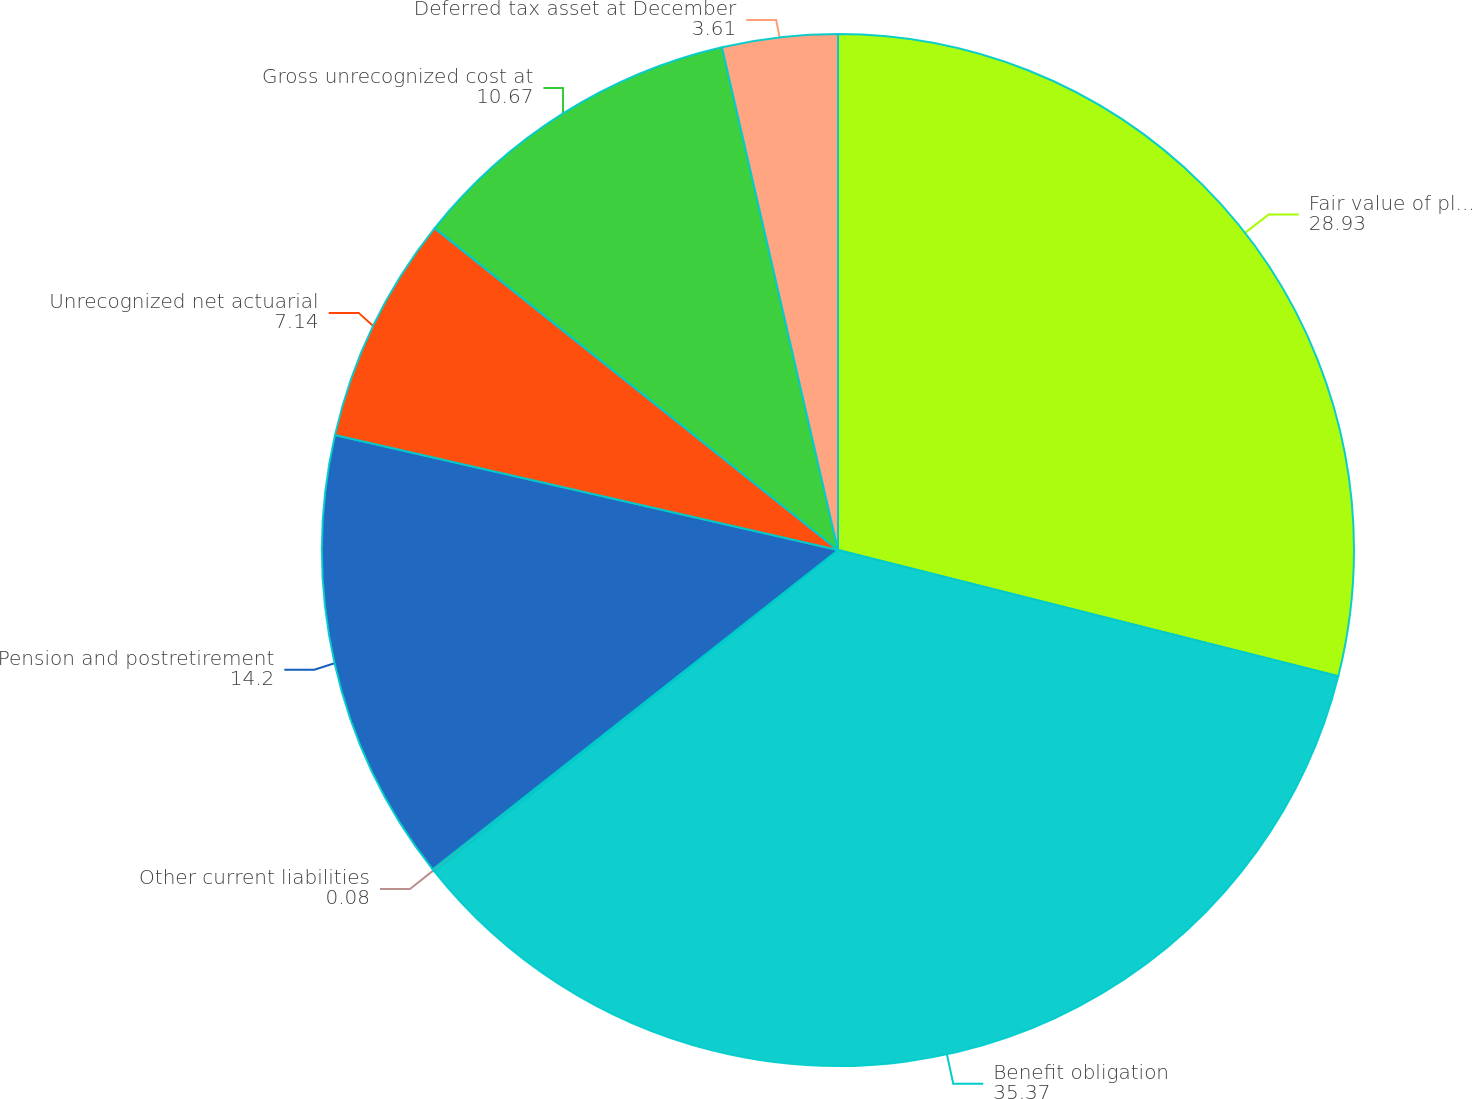<chart> <loc_0><loc_0><loc_500><loc_500><pie_chart><fcel>Fair value of plan assets<fcel>Benefit obligation<fcel>Other current liabilities<fcel>Pension and postretirement<fcel>Unrecognized net actuarial<fcel>Gross unrecognized cost at<fcel>Deferred tax asset at December<nl><fcel>28.93%<fcel>35.37%<fcel>0.08%<fcel>14.2%<fcel>7.14%<fcel>10.67%<fcel>3.61%<nl></chart> 